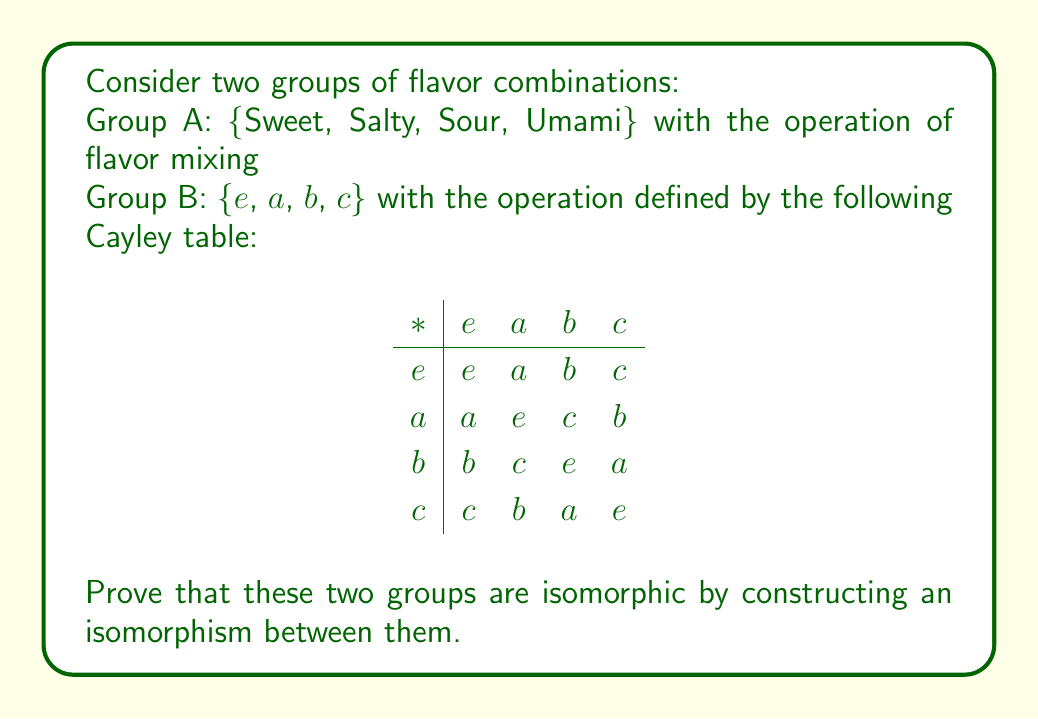Give your solution to this math problem. To prove that the two groups are isomorphic, we need to find a bijective function $f$ from Group A to Group B that preserves the group operation. Let's approach this step-by-step:

1. First, let's identify the structure of Group A:
   - Sweet (S) can be considered the identity element
   - Mixing any flavor with itself returns to Sweet
   - Mixing any two different flavors results in the third flavor

2. Now, let's construct a mapping $f$ from Group A to Group B:
   $f(Sweet) = e$
   $f(Salty) = a$
   $f(Sour) = b$
   $f(Umami) = c$

3. To prove this is an isomorphism, we need to show:
   a) $f$ is bijective (one-to-one and onto)
   b) $f$ preserves the group operation: $f(x * y) = f(x) * f(y)$ for all $x, y$ in Group A

4. Bijectivity:
   - $f$ is clearly one-to-one as each element in Group A maps to a unique element in Group B
   - $f$ is onto as every element in Group B is mapped to by an element in Group A

5. Preserving the group operation:
   - $f(Sweet * Sweet) = f(Sweet) = e = e * e = f(Sweet) * f(Sweet)$
   - $f(Salty * Salty) = f(Sweet) = e = a * a = f(Salty) * f(Salty)$
   - $f(Sour * Sour) = f(Sweet) = e = b * b = f(Sour) * f(Sour)$
   - $f(Umami * Umami) = f(Sweet) = e = c * c = f(Umami) * f(Umami)$
   - $f(Salty * Sour) = f(Umami) = c = a * b = f(Salty) * f(Sour)$
   - $f(Sour * Umami) = f(Salty) = a = b * c = f(Sour) * f(Umami)$
   - $f(Umami * Salty) = f(Sour) = b = c * a = f(Umami) * f(Salty)$

6. We can verify that all other combinations preserve the group operation in a similar manner.

Therefore, $f$ is an isomorphism between Group A and Group B, proving that the two groups are isomorphic.
Answer: The isomorphism $f$ from Group A to Group B is:

$f(Sweet) = e$
$f(Salty) = a$
$f(Sour) = b$
$f(Umami) = c$

This mapping preserves the group operation and is bijective, thus proving that the two groups are isomorphic. 